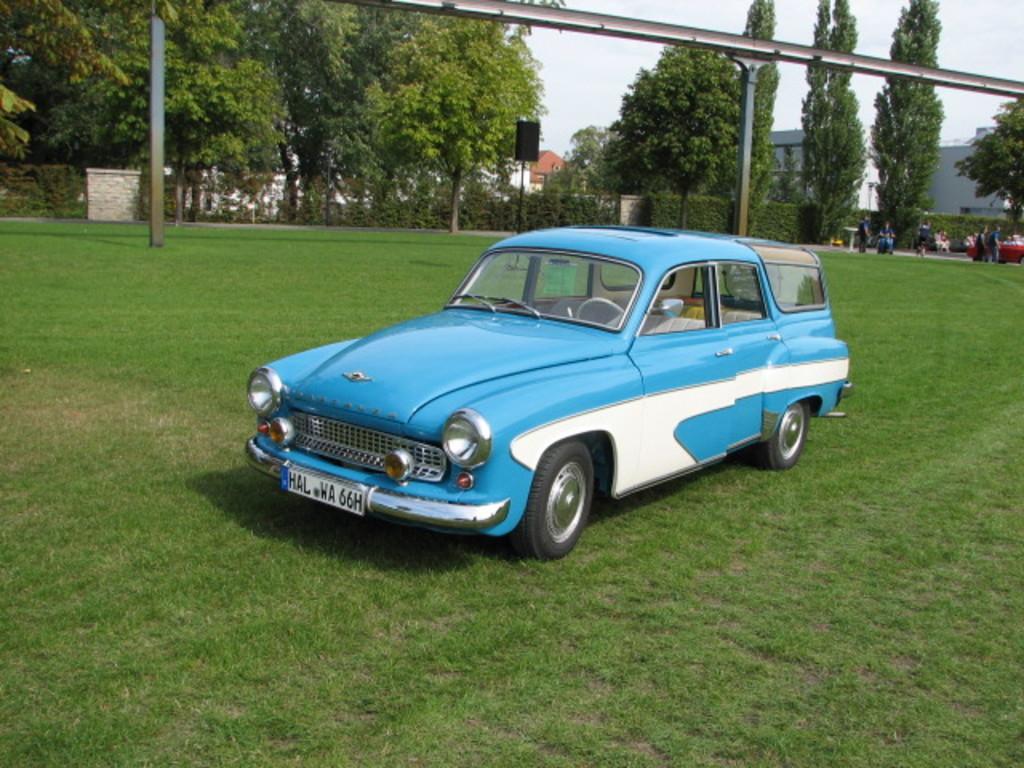Please provide a concise description of this image. In this image, we can see vehicles and there are some people. In the background, there are houses, trees, a board and we can see rods. At the top, there is sky and at the bottom, there is ground. 